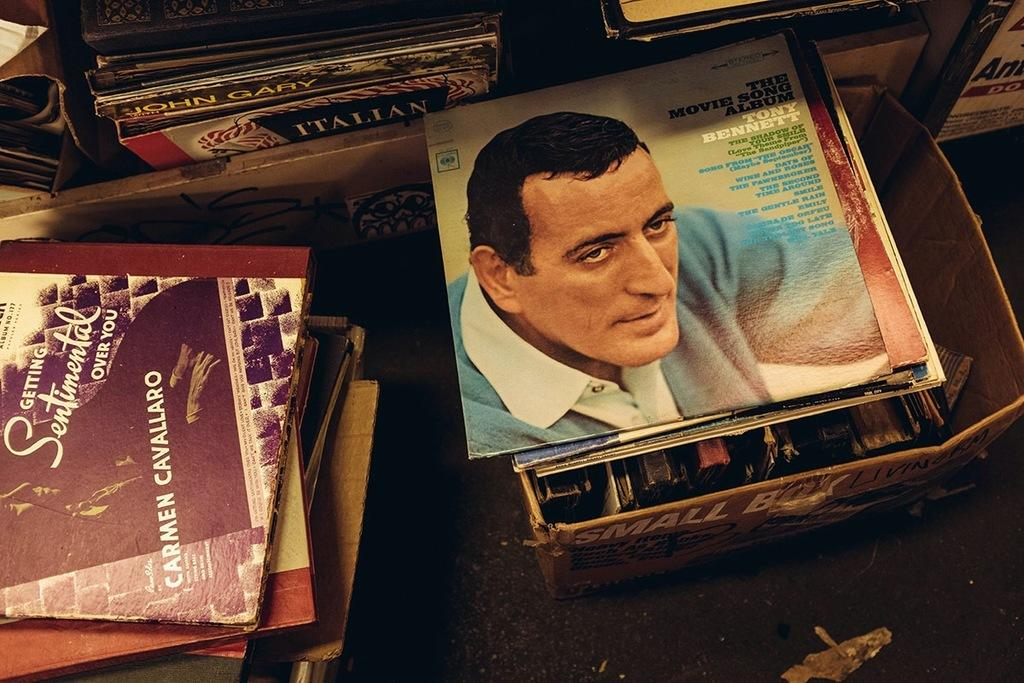Provide a one-sentence caption for the provided image. A variety of records including one by Tony Bennet, the Movie Song Album. 